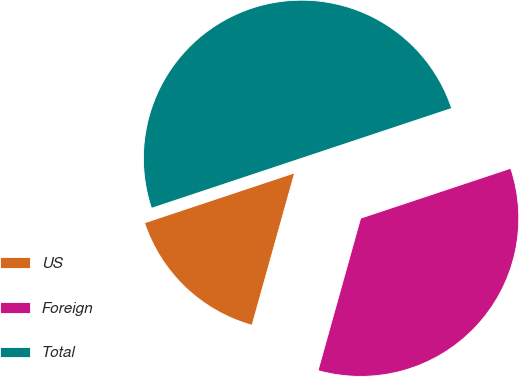<chart> <loc_0><loc_0><loc_500><loc_500><pie_chart><fcel>US<fcel>Foreign<fcel>Total<nl><fcel>15.55%<fcel>34.45%<fcel>50.0%<nl></chart> 